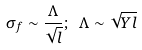Convert formula to latex. <formula><loc_0><loc_0><loc_500><loc_500>\sigma _ { f } \sim \frac { \Lambda } { \sqrt { l } } ; \ \Lambda \sim \sqrt { Y l }</formula> 